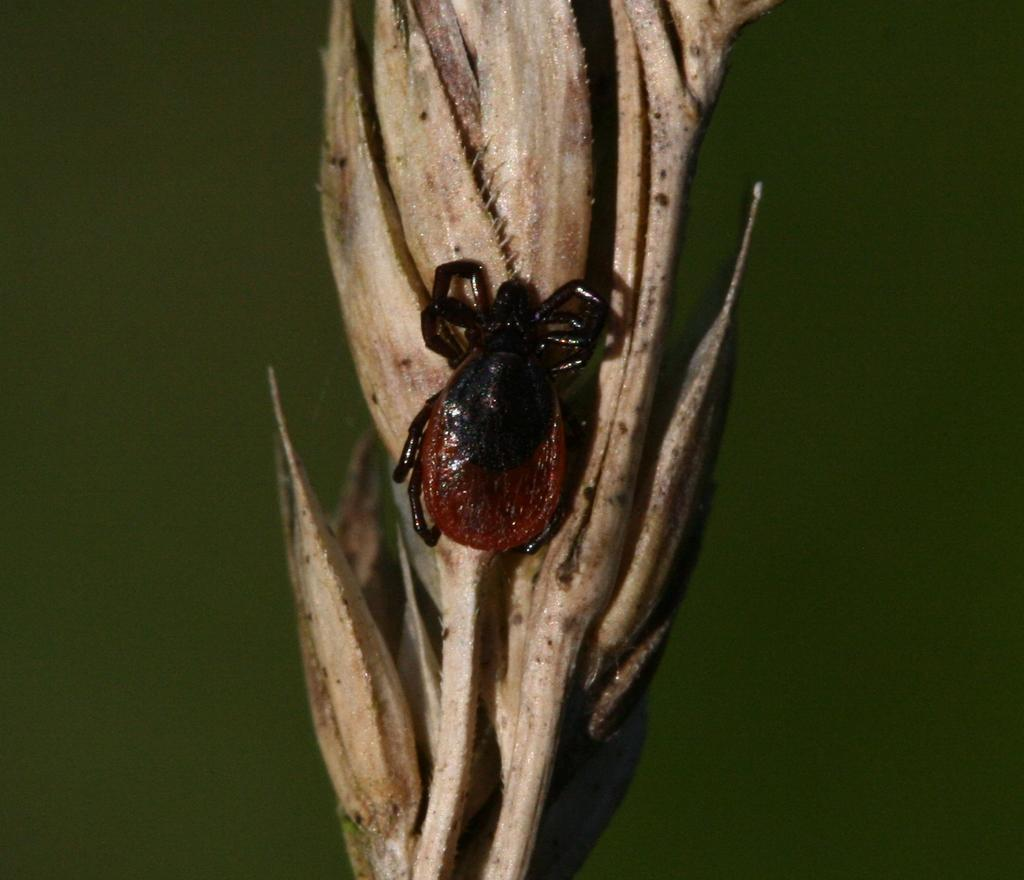What is present on the plant in the image? There is a bug on the plant in the image. What can be observed about the background of the image? The background of the image is dark. Is there a hammer being used to stretch the bug in the image? No, there is no hammer or stretching of the bug in the image. The bug is simply present on the plant. 